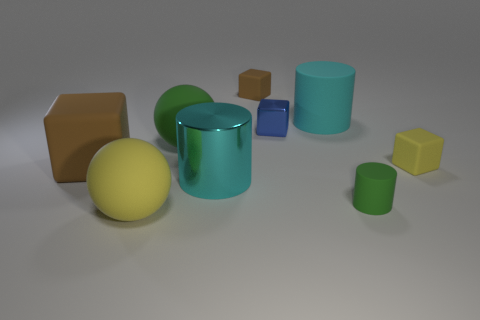What shape is the yellow thing on the right side of the large matte object that is in front of the small rubber cylinder?
Provide a short and direct response. Cube. How many yellow rubber things are in front of the tiny yellow rubber object?
Your response must be concise. 1. Does the yellow ball have the same material as the brown thing that is on the right side of the large cyan shiny thing?
Offer a terse response. Yes. Is there a metallic cylinder of the same size as the metallic cube?
Provide a succinct answer. No. Are there an equal number of big matte objects in front of the yellow rubber cube and big cubes?
Your response must be concise. No. The cyan matte object has what size?
Your answer should be very brief. Large. What number of large brown rubber cubes are behind the large cyan object that is in front of the blue shiny cube?
Provide a succinct answer. 1. There is a large rubber thing that is in front of the green matte ball and on the right side of the big block; what is its shape?
Make the answer very short. Sphere. What number of metallic cylinders have the same color as the big cube?
Provide a succinct answer. 0. There is a large ball that is in front of the large cyan cylinder that is in front of the big brown cube; are there any large cylinders that are to the left of it?
Your answer should be very brief. No. 